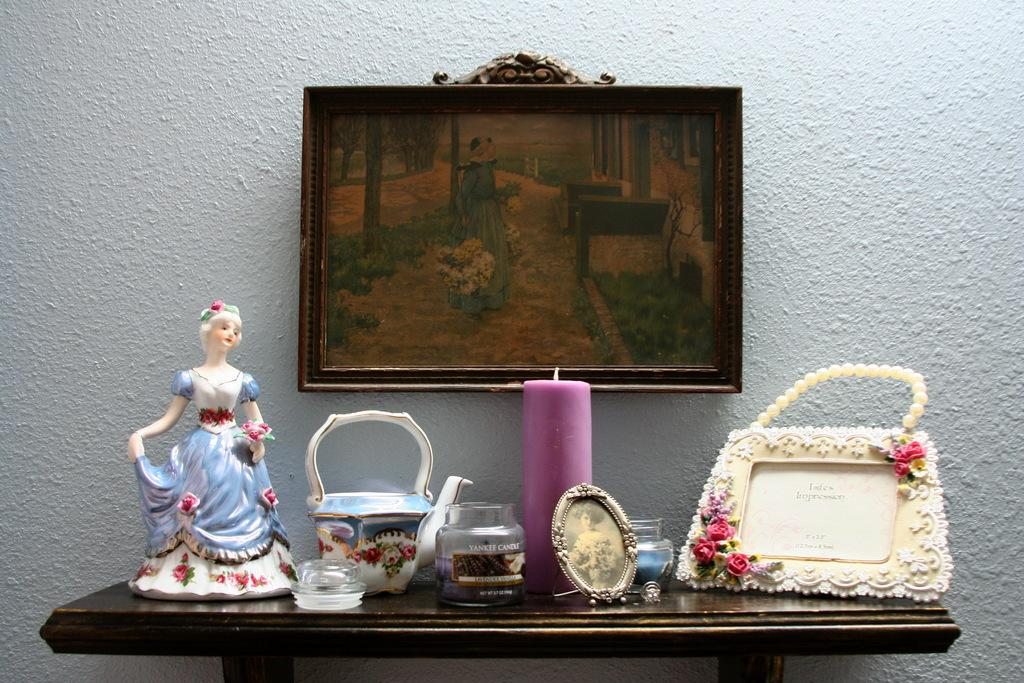What is the main piece of furniture in the image? There is a table in the image. What objects are placed on the table? There are dolls and cattle figures on the table. Is there any light source on the table? Yes, there is a candle on the table. What can be seen on the wall in the image? There is a photo frame on the wall. What type of body is visible in the image? There is no body present in the image; it features a table with dolls, cattle figures, a candle, and a photo frame. How is the table divided into sections in the image? The table is not divided into sections in the image; it is a single, continuous surface. 